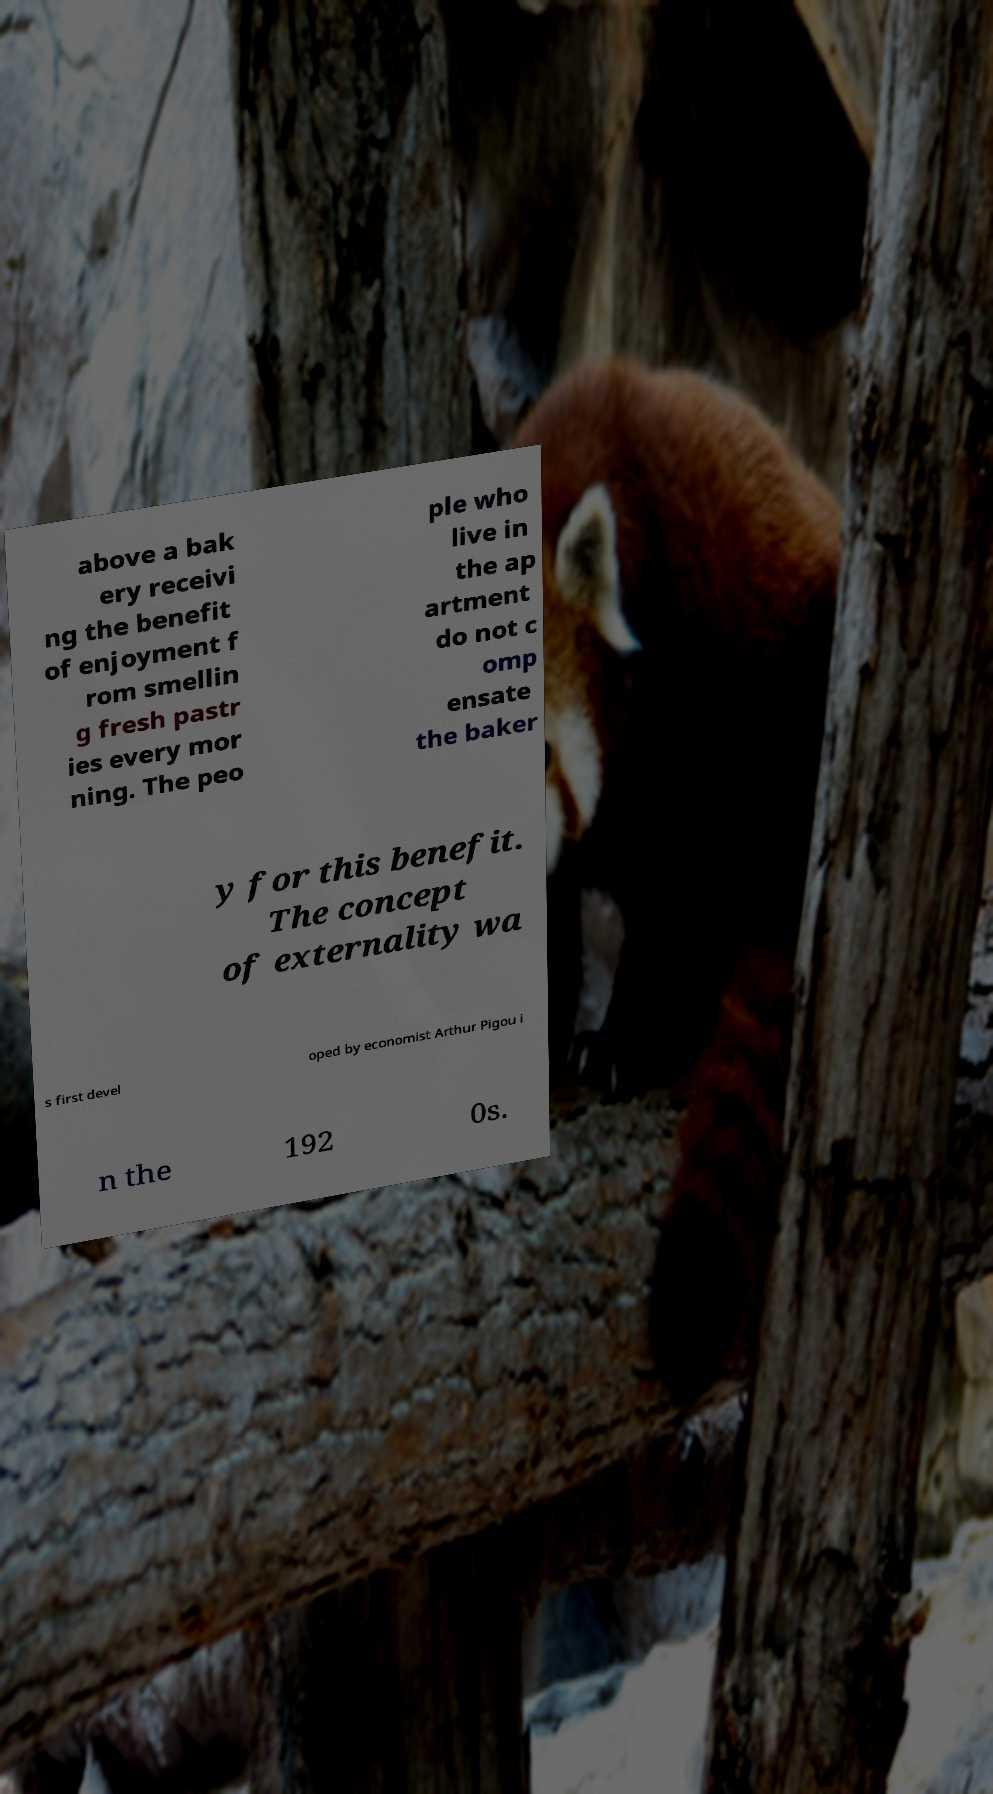There's text embedded in this image that I need extracted. Can you transcribe it verbatim? above a bak ery receivi ng the benefit of enjoyment f rom smellin g fresh pastr ies every mor ning. The peo ple who live in the ap artment do not c omp ensate the baker y for this benefit. The concept of externality wa s first devel oped by economist Arthur Pigou i n the 192 0s. 